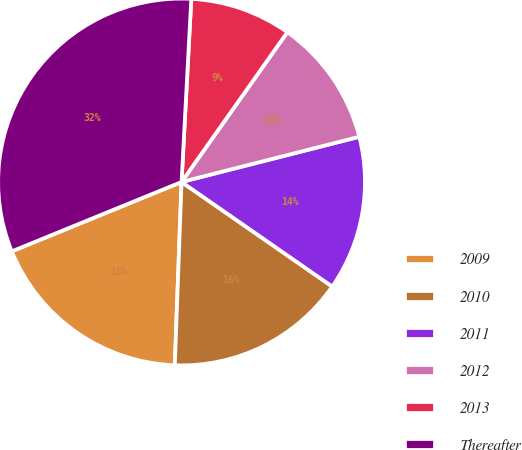Convert chart to OTSL. <chart><loc_0><loc_0><loc_500><loc_500><pie_chart><fcel>2009<fcel>2010<fcel>2011<fcel>2012<fcel>2013<fcel>Thereafter<nl><fcel>18.24%<fcel>15.93%<fcel>13.62%<fcel>11.25%<fcel>8.94%<fcel>32.02%<nl></chart> 